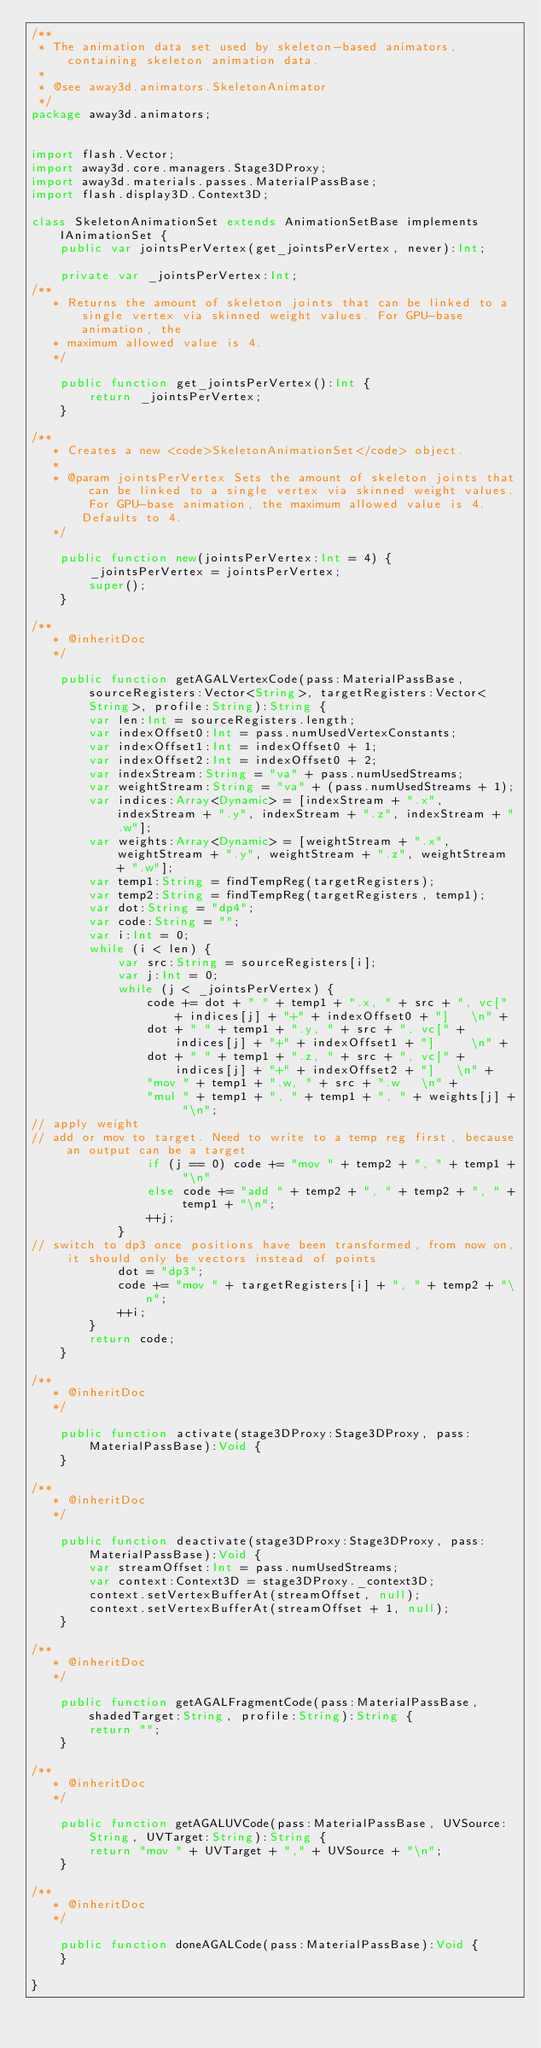<code> <loc_0><loc_0><loc_500><loc_500><_Haxe_>/**
 * The animation data set used by skeleton-based animators, containing skeleton animation data.
 *
 * @see away3d.animators.SkeletonAnimator
 */
package away3d.animators;


import flash.Vector;
import away3d.core.managers.Stage3DProxy;
import away3d.materials.passes.MaterialPassBase;
import flash.display3D.Context3D;

class SkeletonAnimationSet extends AnimationSetBase implements IAnimationSet {
    public var jointsPerVertex(get_jointsPerVertex, never):Int;

    private var _jointsPerVertex:Int;
/**
	 * Returns the amount of skeleton joints that can be linked to a single vertex via skinned weight values. For GPU-base animation, the
	 * maximum allowed value is 4.
	 */

    public function get_jointsPerVertex():Int {
        return _jointsPerVertex;
    }

/**
	 * Creates a new <code>SkeletonAnimationSet</code> object.
	 *
	 * @param jointsPerVertex Sets the amount of skeleton joints that can be linked to a single vertex via skinned weight values. For GPU-base animation, the maximum allowed value is 4. Defaults to 4.
	 */

    public function new(jointsPerVertex:Int = 4) {
        _jointsPerVertex = jointsPerVertex;
        super();
    }

/**
	 * @inheritDoc
	 */

    public function getAGALVertexCode(pass:MaterialPassBase, sourceRegisters:Vector<String>, targetRegisters:Vector<String>, profile:String):String {
        var len:Int = sourceRegisters.length;
        var indexOffset0:Int = pass.numUsedVertexConstants;
        var indexOffset1:Int = indexOffset0 + 1;
        var indexOffset2:Int = indexOffset0 + 2;
        var indexStream:String = "va" + pass.numUsedStreams;
        var weightStream:String = "va" + (pass.numUsedStreams + 1);
        var indices:Array<Dynamic> = [indexStream + ".x", indexStream + ".y", indexStream + ".z", indexStream + ".w"];
        var weights:Array<Dynamic> = [weightStream + ".x", weightStream + ".y", weightStream + ".z", weightStream + ".w"];
        var temp1:String = findTempReg(targetRegisters);
        var temp2:String = findTempReg(targetRegisters, temp1);
        var dot:String = "dp4";
        var code:String = "";
        var i:Int = 0;
        while (i < len) {
            var src:String = sourceRegisters[i];
            var j:Int = 0;
            while (j < _jointsPerVertex) {
                code += dot + " " + temp1 + ".x, " + src + ", vc[" + indices[j] + "+" + indexOffset0 + "]		\n" +
                dot + " " + temp1 + ".y, " + src + ", vc[" + indices[j] + "+" + indexOffset1 + "]    	\n" +
                dot + " " + temp1 + ".z, " + src + ", vc[" + indices[j] + "+" + indexOffset2 + "]		\n" +
                "mov " + temp1 + ".w, " + src + ".w		\n" +
                "mul " + temp1 + ", " + temp1 + ", " + weights[j] + "\n";
// apply weight
// add or mov to target. Need to write to a temp reg first, because an output can be a target
                if (j == 0) code += "mov " + temp2 + ", " + temp1 + "\n"
                else code += "add " + temp2 + ", " + temp2 + ", " + temp1 + "\n";
                ++j;
            }
// switch to dp3 once positions have been transformed, from now on, it should only be vectors instead of points
            dot = "dp3";
            code += "mov " + targetRegisters[i] + ", " + temp2 + "\n";
            ++i;
        }
        return code;
    }

/**
	 * @inheritDoc
	 */

    public function activate(stage3DProxy:Stage3DProxy, pass:MaterialPassBase):Void {
    }

/**
	 * @inheritDoc
	 */

    public function deactivate(stage3DProxy:Stage3DProxy, pass:MaterialPassBase):Void {
        var streamOffset:Int = pass.numUsedStreams;
        var context:Context3D = stage3DProxy._context3D;
        context.setVertexBufferAt(streamOffset, null);
        context.setVertexBufferAt(streamOffset + 1, null);
    }

/**
	 * @inheritDoc
	 */

    public function getAGALFragmentCode(pass:MaterialPassBase, shadedTarget:String, profile:String):String {
        return "";
    }

/**
	 * @inheritDoc
	 */

    public function getAGALUVCode(pass:MaterialPassBase, UVSource:String, UVTarget:String):String {
        return "mov " + UVTarget + "," + UVSource + "\n";
    }

/**
	 * @inheritDoc
	 */

    public function doneAGALCode(pass:MaterialPassBase):Void {
    }

}

</code> 